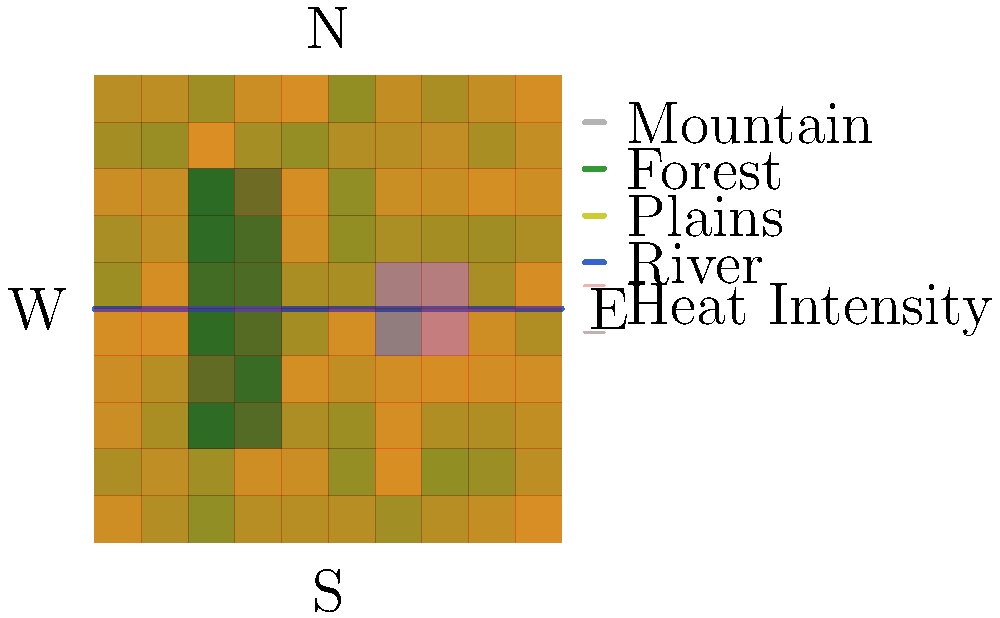Based on the terrain heat map provided, which direction is the enemy force most likely to advance, and what tactical considerations should be taken into account for a potential ambush? To analyze the potential enemy movement and plan an ambush, we need to consider several factors:

1. Terrain analysis:
   - Mountains in the northeast quadrant provide a natural barrier
   - Forest in the western part offers cover and concealment
   - River running east-west divides the map into north and south sections
   - Plains in the south and east offer open ground

2. Heat map interpretation:
   - Higher intensity (darker red) indicates more likely enemy presence or movement
   - The heat map shows higher intensity in the southeastern quadrant

3. Tactical considerations:
   - Enemy is likely to avoid the mountainous region due to difficult terrain
   - The forest provides cover but may slow movement
   - The river acts as a natural obstacle, but also a potential choke point
   - Open plains allow for faster movement but offer less cover

4. Most probable course of action:
   - Based on the heat map and terrain, the enemy is most likely to advance from the southeast towards the northwest
   - They may attempt to cross the river where it intersects with the forest for added concealment

5. Ambush planning:
   - Ideal ambush locations would be:
     a) Near the river crossing point in the forest
     b) At the edge of the forest facing the open plains
   - These positions offer concealment for the ambushing force and exploit natural choke points

6. Additional considerations:
   - Establish observation posts in elevated positions (e.g., mountains) to monitor enemy movement
   - Prepare multiple ambush sites to adapt to enemy route changes
   - Consider using the river as a natural barrier to funnel enemy forces into the ambush kill zone
Answer: Southeast to Northwest; ambush near forest-river intersection 